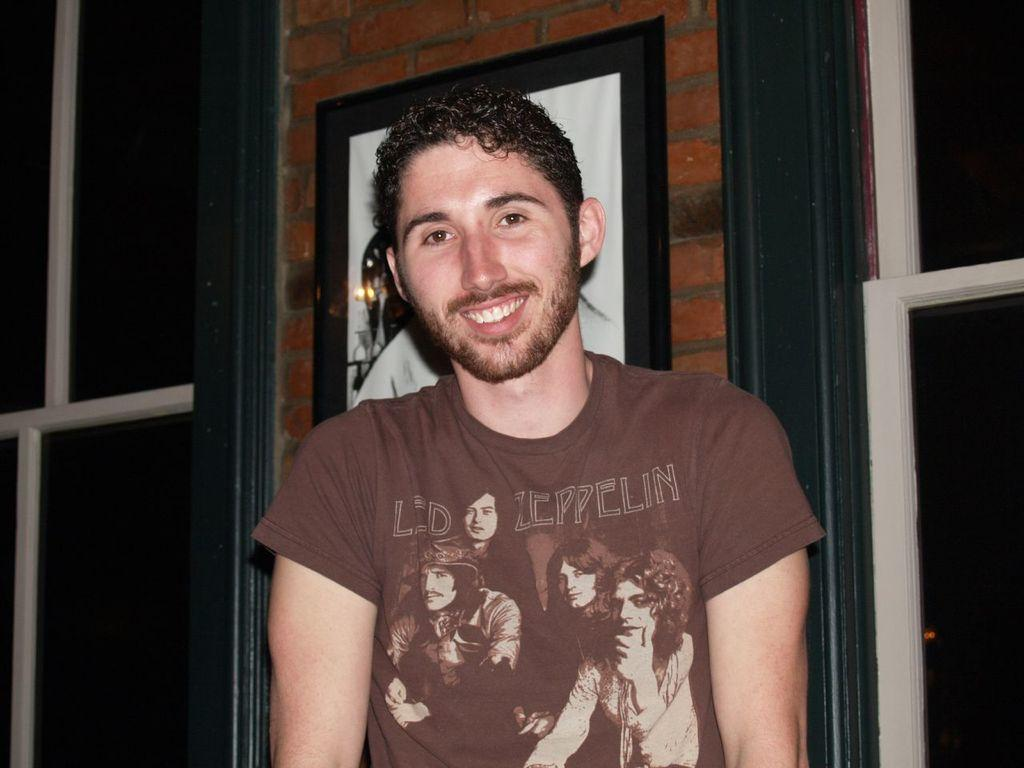What is the main subject of the image? The main subject of the image is a man standing. What is the man wearing in the image? The man is wearing a t-shirt in the image. What is the man's facial expression in the image? The man is smiling in the image. What can be seen in the background of the image? There is a brick wall in the background of the image. What is on the brick wall in the image? The brick wall has a photo on it. What type of toothpaste is the man using in the image? There is no toothpaste present in the image, and the man is not using any toothpaste. Can you tell me how many aunts are visible in the image? There are no aunts visible in the image; the main subject is a man standing. 